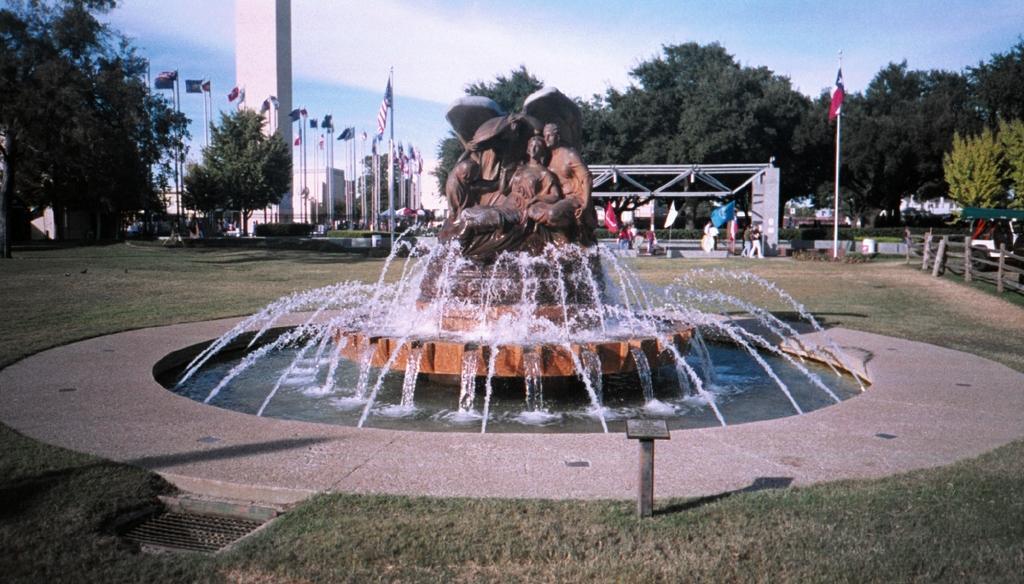Describe this image in one or two sentences. In the center of the image we can see the fountain. On the fountain, we can see statues. At the bottom of the image we can see the grass, one pole and some object. In the background, we can see the sky, clouds, poles, pillars, flags, trees, grass, few people are standing, fence and a few other objects. 